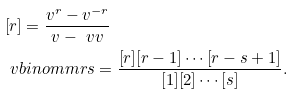Convert formula to latex. <formula><loc_0><loc_0><loc_500><loc_500>& [ r ] = \frac { v ^ { r } - v ^ { - r } } { v - \ v v } \\ & \ v b i n o m m { r } { s } = \frac { [ r ] [ r - 1 ] \cdots [ r - s + 1 ] } { [ 1 ] [ 2 ] \cdots [ s ] } .</formula> 